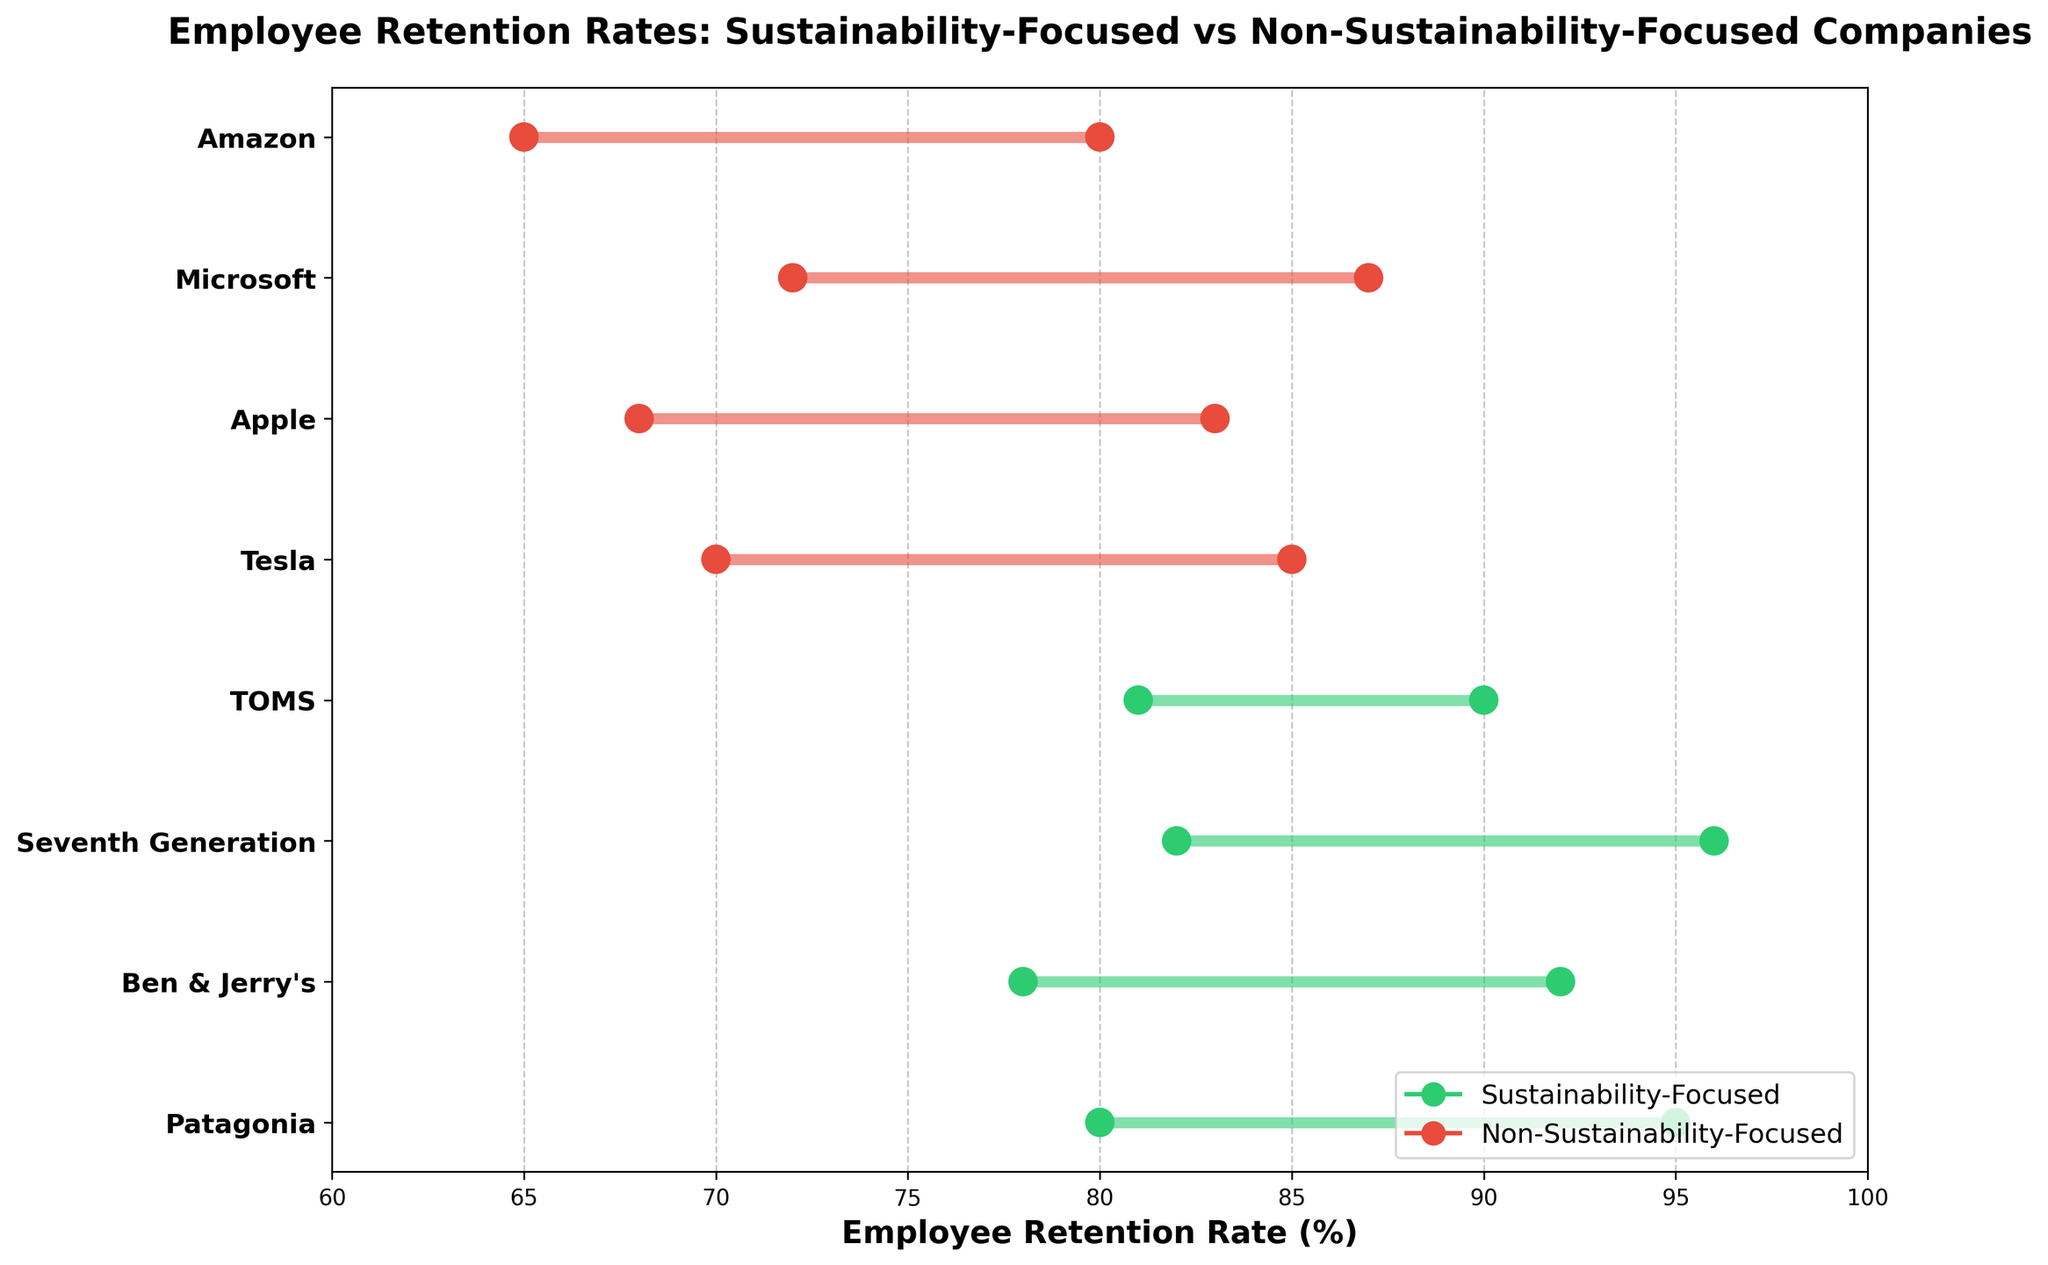What is the title of the figure? The title of a plot is usually found at the top center, providing an overview of what the plot represents. In this figure, the title reads "Employee Retention Rates: Sustainability-Focused vs Non-Sustainability-Focused Companies".
Answer: Employee Retention Rates: Sustainability-Focused vs Non-Sustainability-Focused Companies What is the maximum retention rate for Patagonia? To determine this, identify the horizontal line corresponding to Patagonia and look at the maximum end. The maximum retention rate for Patagonia is 95%.
Answer: 95% Which company has the lowest minimum retention rate? Compare the minimum points of each company's line. Amazon has the lowest minimum retention rate of 65%.
Answer: Amazon Calculate the average of the maximum retention rates for sustainability-focused companies. Add the maximum rates for Patagonia (95%), Ben & Jerry's (92%), Seventh Generation (96%), and TOMS (90%). Divide by 4 to find the average: \((95 + 92 + 96 + 90) / 4 = 373 / 4 = 93.25\).
Answer: 93.25 Compare the overall spread (range) of retention rates for Tesla and Apple. Which company has a narrower range? Calculate the range for Tesla (85 - 70 = 15) and Apple (83 - 68 = 15). Both companies have the same range of 15.
Answer: They have the same range Which sustainability-focused company has the highest minimum retention rate? Identify all the sustainability-focused companies and compare their minimum retention rates. Seventh Generation has the highest minimum retention rate of 82%.
Answer: Seventh Generation What is the difference between the maximum retention rates of the highest and lowest companies overall? Indentify the highest overall retention rate (Seventh Generation, 96%) and the lowest overall (Amazon, 80%). Subtract the lower from the higher: \(96 - 80 = 31\).
Answer: 31 Among non-sustainability-focused companies, which one has the highest minimum retention rate? Compare the minimum retention rates of Tesla (70%), Apple (68%), Microsoft (72%), and Amazon (65%). Microsoft has the highest minimum retention rate of 72%.
Answer: Microsoft Which type of company (sustainability-focused or non-sustainability-focused) generally shows higher maximum retention rates? For sustainability-focused companies (Patagonia, Ben & Jerry's, Seventh Generation, TOMS), the maximum rates are 95%, 92%, 96%, and 90%. For non-sustainability-focused companies (Tesla, Apple, Microsoft, Amazon), the maximum rates are 85%, 83%, 87%, and 80%. The sustainability-focused companies generally show higher maximum rates.
Answer: Sustainability-Focused 